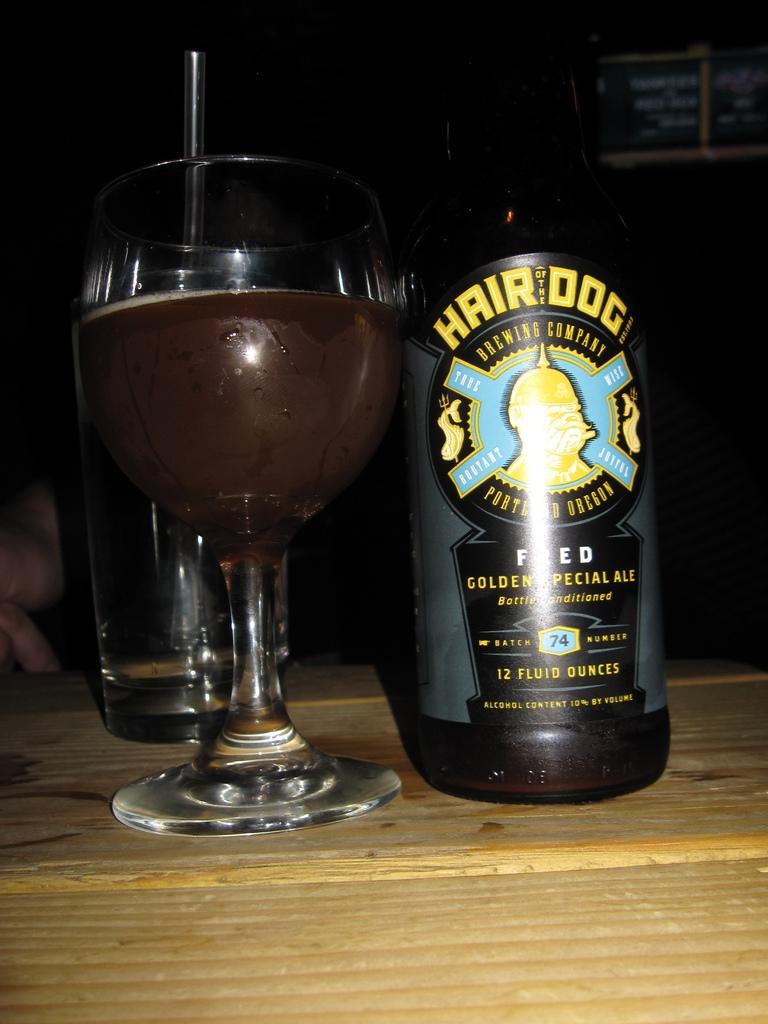What is the name of the drink in the bottle?
Your answer should be very brief. Hair of the dog. How many ounces in this bottle?
Your answer should be compact. 12. 